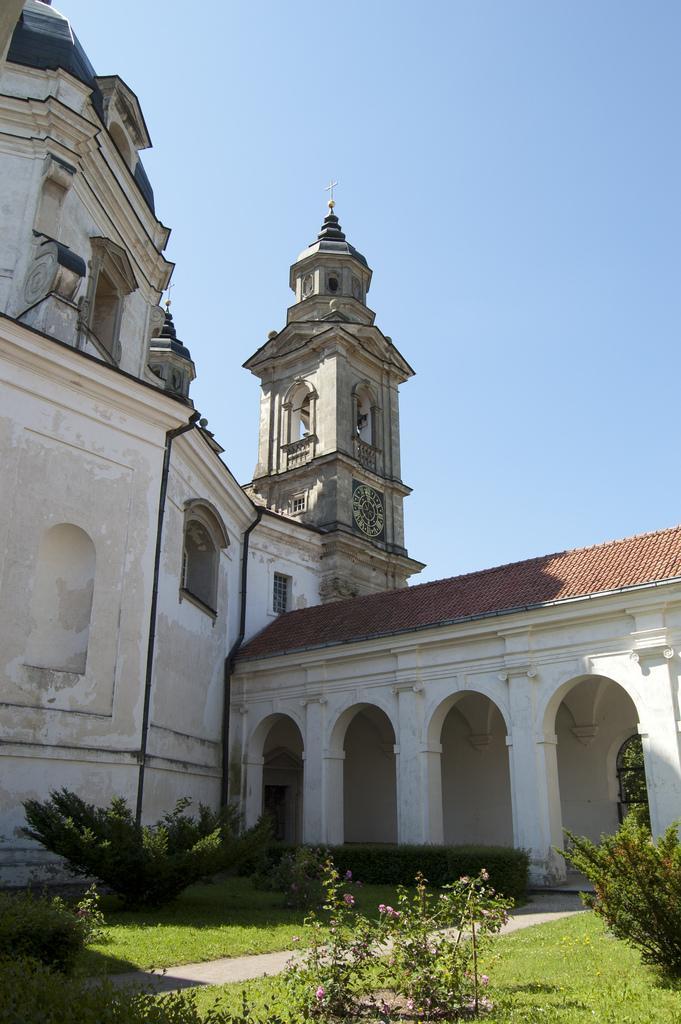Describe this image in one or two sentences. In this picture we can see grass at the bottom, there are some plants and shrubs here, in the background we can see a building, there is the sky at the top of the picture. 